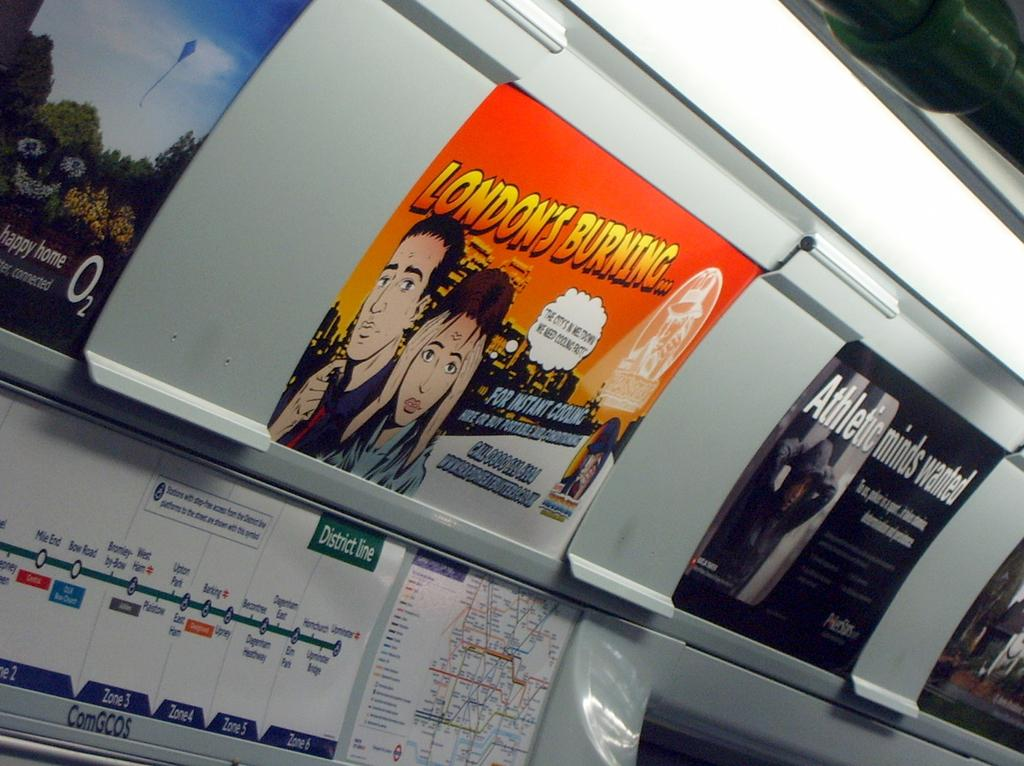<image>
Present a compact description of the photo's key features. Advertisements on a train tall include one that says London's Burning. 